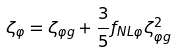Convert formula to latex. <formula><loc_0><loc_0><loc_500><loc_500>\zeta _ { \varphi } = \zeta _ { \varphi g } + \frac { 3 } { 5 } f _ { N L \varphi } \zeta _ { \varphi g } ^ { 2 }</formula> 